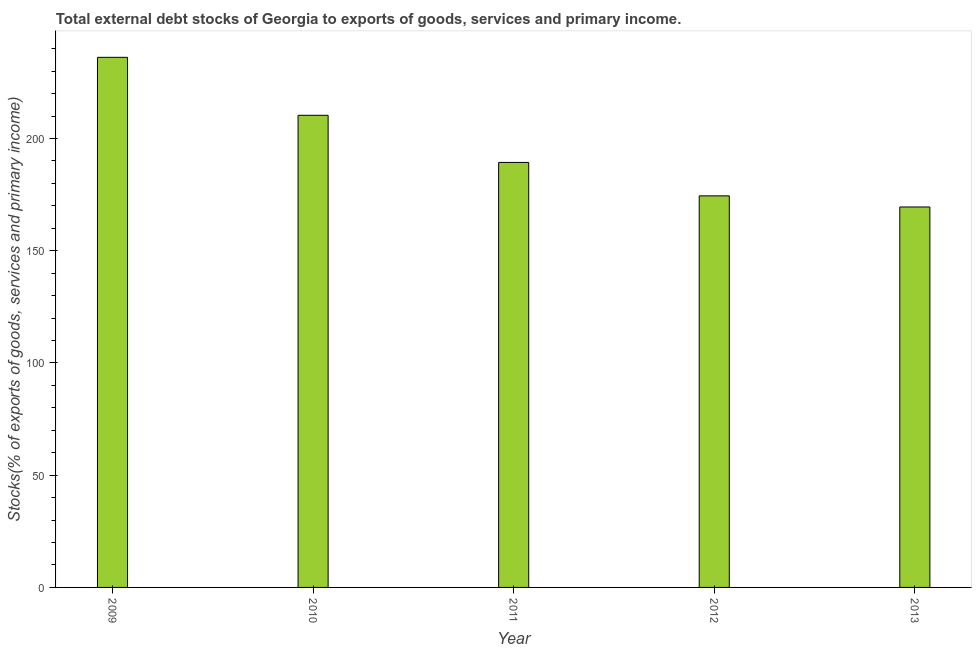Does the graph contain grids?
Your answer should be compact. No. What is the title of the graph?
Offer a terse response. Total external debt stocks of Georgia to exports of goods, services and primary income. What is the label or title of the X-axis?
Provide a succinct answer. Year. What is the label or title of the Y-axis?
Make the answer very short. Stocks(% of exports of goods, services and primary income). What is the external debt stocks in 2010?
Give a very brief answer. 210.35. Across all years, what is the maximum external debt stocks?
Provide a short and direct response. 236.17. Across all years, what is the minimum external debt stocks?
Offer a very short reply. 169.5. In which year was the external debt stocks minimum?
Your answer should be compact. 2013. What is the sum of the external debt stocks?
Offer a very short reply. 979.81. What is the difference between the external debt stocks in 2011 and 2013?
Your answer should be compact. 19.84. What is the average external debt stocks per year?
Offer a very short reply. 195.96. What is the median external debt stocks?
Provide a short and direct response. 189.34. In how many years, is the external debt stocks greater than 210 %?
Provide a short and direct response. 2. What is the ratio of the external debt stocks in 2009 to that in 2010?
Ensure brevity in your answer.  1.12. What is the difference between the highest and the second highest external debt stocks?
Ensure brevity in your answer.  25.82. What is the difference between the highest and the lowest external debt stocks?
Provide a short and direct response. 66.67. In how many years, is the external debt stocks greater than the average external debt stocks taken over all years?
Give a very brief answer. 2. How many bars are there?
Your answer should be compact. 5. Are all the bars in the graph horizontal?
Your answer should be very brief. No. What is the difference between two consecutive major ticks on the Y-axis?
Make the answer very short. 50. Are the values on the major ticks of Y-axis written in scientific E-notation?
Provide a short and direct response. No. What is the Stocks(% of exports of goods, services and primary income) in 2009?
Ensure brevity in your answer.  236.17. What is the Stocks(% of exports of goods, services and primary income) of 2010?
Offer a terse response. 210.35. What is the Stocks(% of exports of goods, services and primary income) of 2011?
Provide a short and direct response. 189.34. What is the Stocks(% of exports of goods, services and primary income) in 2012?
Your answer should be compact. 174.45. What is the Stocks(% of exports of goods, services and primary income) of 2013?
Offer a very short reply. 169.5. What is the difference between the Stocks(% of exports of goods, services and primary income) in 2009 and 2010?
Provide a succinct answer. 25.82. What is the difference between the Stocks(% of exports of goods, services and primary income) in 2009 and 2011?
Provide a succinct answer. 46.83. What is the difference between the Stocks(% of exports of goods, services and primary income) in 2009 and 2012?
Offer a very short reply. 61.72. What is the difference between the Stocks(% of exports of goods, services and primary income) in 2009 and 2013?
Ensure brevity in your answer.  66.67. What is the difference between the Stocks(% of exports of goods, services and primary income) in 2010 and 2011?
Provide a succinct answer. 21.01. What is the difference between the Stocks(% of exports of goods, services and primary income) in 2010 and 2012?
Make the answer very short. 35.9. What is the difference between the Stocks(% of exports of goods, services and primary income) in 2010 and 2013?
Ensure brevity in your answer.  40.85. What is the difference between the Stocks(% of exports of goods, services and primary income) in 2011 and 2012?
Your answer should be very brief. 14.89. What is the difference between the Stocks(% of exports of goods, services and primary income) in 2011 and 2013?
Make the answer very short. 19.84. What is the difference between the Stocks(% of exports of goods, services and primary income) in 2012 and 2013?
Keep it short and to the point. 4.95. What is the ratio of the Stocks(% of exports of goods, services and primary income) in 2009 to that in 2010?
Your answer should be very brief. 1.12. What is the ratio of the Stocks(% of exports of goods, services and primary income) in 2009 to that in 2011?
Offer a very short reply. 1.25. What is the ratio of the Stocks(% of exports of goods, services and primary income) in 2009 to that in 2012?
Offer a very short reply. 1.35. What is the ratio of the Stocks(% of exports of goods, services and primary income) in 2009 to that in 2013?
Offer a terse response. 1.39. What is the ratio of the Stocks(% of exports of goods, services and primary income) in 2010 to that in 2011?
Give a very brief answer. 1.11. What is the ratio of the Stocks(% of exports of goods, services and primary income) in 2010 to that in 2012?
Your answer should be compact. 1.21. What is the ratio of the Stocks(% of exports of goods, services and primary income) in 2010 to that in 2013?
Give a very brief answer. 1.24. What is the ratio of the Stocks(% of exports of goods, services and primary income) in 2011 to that in 2012?
Your answer should be very brief. 1.08. What is the ratio of the Stocks(% of exports of goods, services and primary income) in 2011 to that in 2013?
Your answer should be compact. 1.12. What is the ratio of the Stocks(% of exports of goods, services and primary income) in 2012 to that in 2013?
Provide a short and direct response. 1.03. 